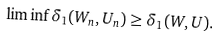Convert formula to latex. <formula><loc_0><loc_0><loc_500><loc_500>\liminf \delta _ { 1 } ( W _ { n } , U _ { n } ) \geq \delta _ { 1 } ( W , U ) .</formula> 